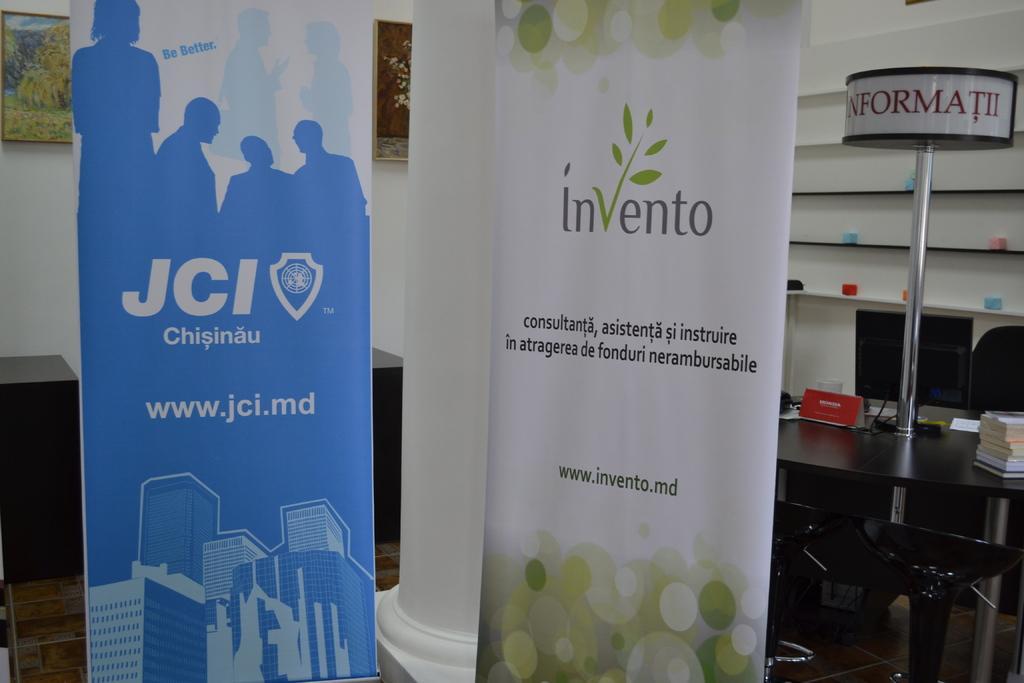Could you give a brief overview of what you see in this image? In the center of the image we can see an advertisements. On the right side of the image we can see books, pole, monitor and cups placed on the table. At the bottom of the image we can see chairs. In the background we can see wall, photo frames and objects arranged in shelves. 